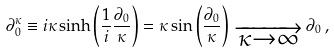<formula> <loc_0><loc_0><loc_500><loc_500>\partial _ { 0 } ^ { \kappa } \equiv i \kappa \sinh \left ( \frac { 1 } { i } \frac { \partial _ { 0 } } { \kappa } \right ) = \kappa \sin \left ( \frac { \partial _ { 0 } } { \kappa } \right ) \, _ { \overrightarrow { { \, \kappa \rightarrow \infty } \, } } \, \partial _ { 0 } \, ,</formula> 